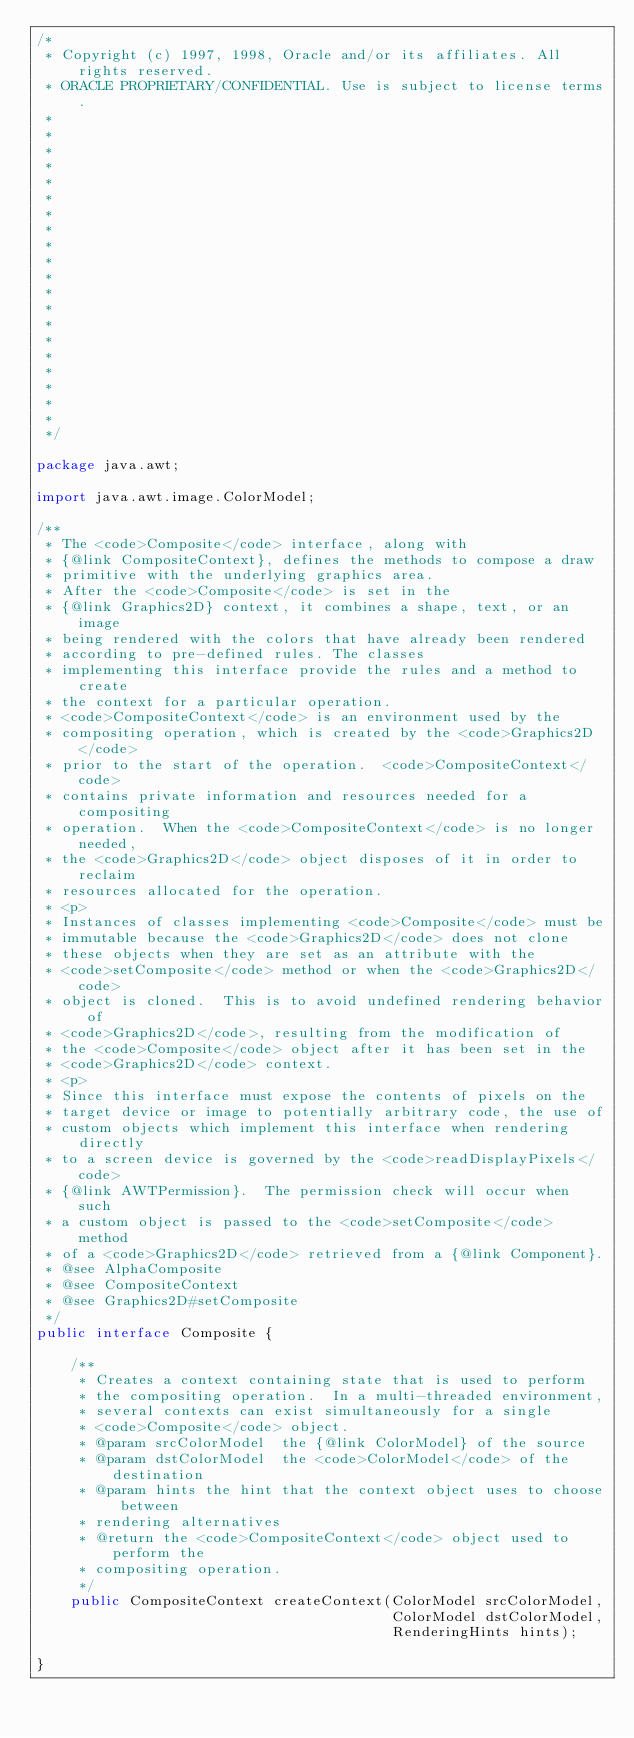<code> <loc_0><loc_0><loc_500><loc_500><_Java_>/*
 * Copyright (c) 1997, 1998, Oracle and/or its affiliates. All rights reserved.
 * ORACLE PROPRIETARY/CONFIDENTIAL. Use is subject to license terms.
 *
 *
 *
 *
 *
 *
 *
 *
 *
 *
 *
 *
 *
 *
 *
 *
 *
 *
 *
 *
 */

package java.awt;

import java.awt.image.ColorModel;

/**
 * The <code>Composite</code> interface, along with
 * {@link CompositeContext}, defines the methods to compose a draw
 * primitive with the underlying graphics area.
 * After the <code>Composite</code> is set in the
 * {@link Graphics2D} context, it combines a shape, text, or an image
 * being rendered with the colors that have already been rendered
 * according to pre-defined rules. The classes
 * implementing this interface provide the rules and a method to create
 * the context for a particular operation.
 * <code>CompositeContext</code> is an environment used by the
 * compositing operation, which is created by the <code>Graphics2D</code>
 * prior to the start of the operation.  <code>CompositeContext</code>
 * contains private information and resources needed for a compositing
 * operation.  When the <code>CompositeContext</code> is no longer needed,
 * the <code>Graphics2D</code> object disposes of it in order to reclaim
 * resources allocated for the operation.
 * <p>
 * Instances of classes implementing <code>Composite</code> must be
 * immutable because the <code>Graphics2D</code> does not clone
 * these objects when they are set as an attribute with the
 * <code>setComposite</code> method or when the <code>Graphics2D</code>
 * object is cloned.  This is to avoid undefined rendering behavior of
 * <code>Graphics2D</code>, resulting from the modification of
 * the <code>Composite</code> object after it has been set in the
 * <code>Graphics2D</code> context.
 * <p>
 * Since this interface must expose the contents of pixels on the
 * target device or image to potentially arbitrary code, the use of
 * custom objects which implement this interface when rendering directly
 * to a screen device is governed by the <code>readDisplayPixels</code>
 * {@link AWTPermission}.  The permission check will occur when such
 * a custom object is passed to the <code>setComposite</code> method
 * of a <code>Graphics2D</code> retrieved from a {@link Component}.
 * @see AlphaComposite
 * @see CompositeContext
 * @see Graphics2D#setComposite
 */
public interface Composite {

    /**
     * Creates a context containing state that is used to perform
     * the compositing operation.  In a multi-threaded environment,
     * several contexts can exist simultaneously for a single
     * <code>Composite</code> object.
     * @param srcColorModel  the {@link ColorModel} of the source
     * @param dstColorModel  the <code>ColorModel</code> of the destination
     * @param hints the hint that the context object uses to choose between
     * rendering alternatives
     * @return the <code>CompositeContext</code> object used to perform the
     * compositing operation.
     */
    public CompositeContext createContext(ColorModel srcColorModel,
                                          ColorModel dstColorModel,
                                          RenderingHints hints);

}
</code> 